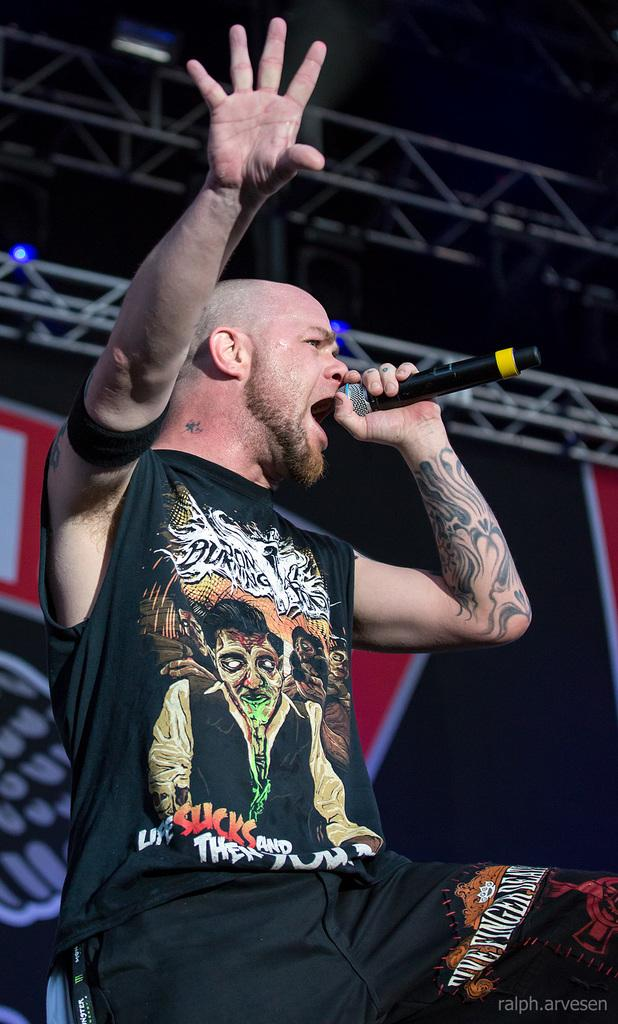What is the man in the image doing? The man is singing in the image. What is the man holding while singing? The man is holding a microphone in his hand. Is there any text visible in the image? Yes, there is text at the bottom right corner of the image. How would you describe the overall lighting in the image? The background of the image is dark. What type of gold jewelry is the man wearing in the image? There is no gold jewelry visible on the man in the image. How many pies can be seen on the table in the image? There is no table or pies present in the image; it features a man singing with a microphone. 